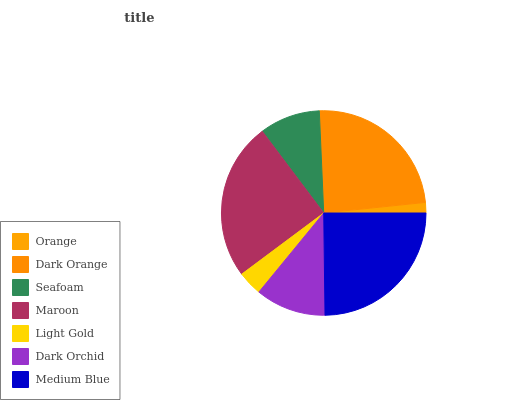Is Orange the minimum?
Answer yes or no. Yes. Is Maroon the maximum?
Answer yes or no. Yes. Is Dark Orange the minimum?
Answer yes or no. No. Is Dark Orange the maximum?
Answer yes or no. No. Is Dark Orange greater than Orange?
Answer yes or no. Yes. Is Orange less than Dark Orange?
Answer yes or no. Yes. Is Orange greater than Dark Orange?
Answer yes or no. No. Is Dark Orange less than Orange?
Answer yes or no. No. Is Dark Orchid the high median?
Answer yes or no. Yes. Is Dark Orchid the low median?
Answer yes or no. Yes. Is Dark Orange the high median?
Answer yes or no. No. Is Dark Orange the low median?
Answer yes or no. No. 